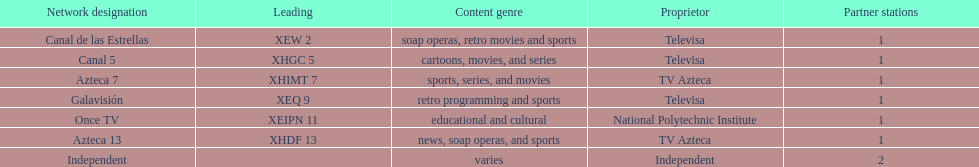What is the total number of affiliates among all the networks? 8. 